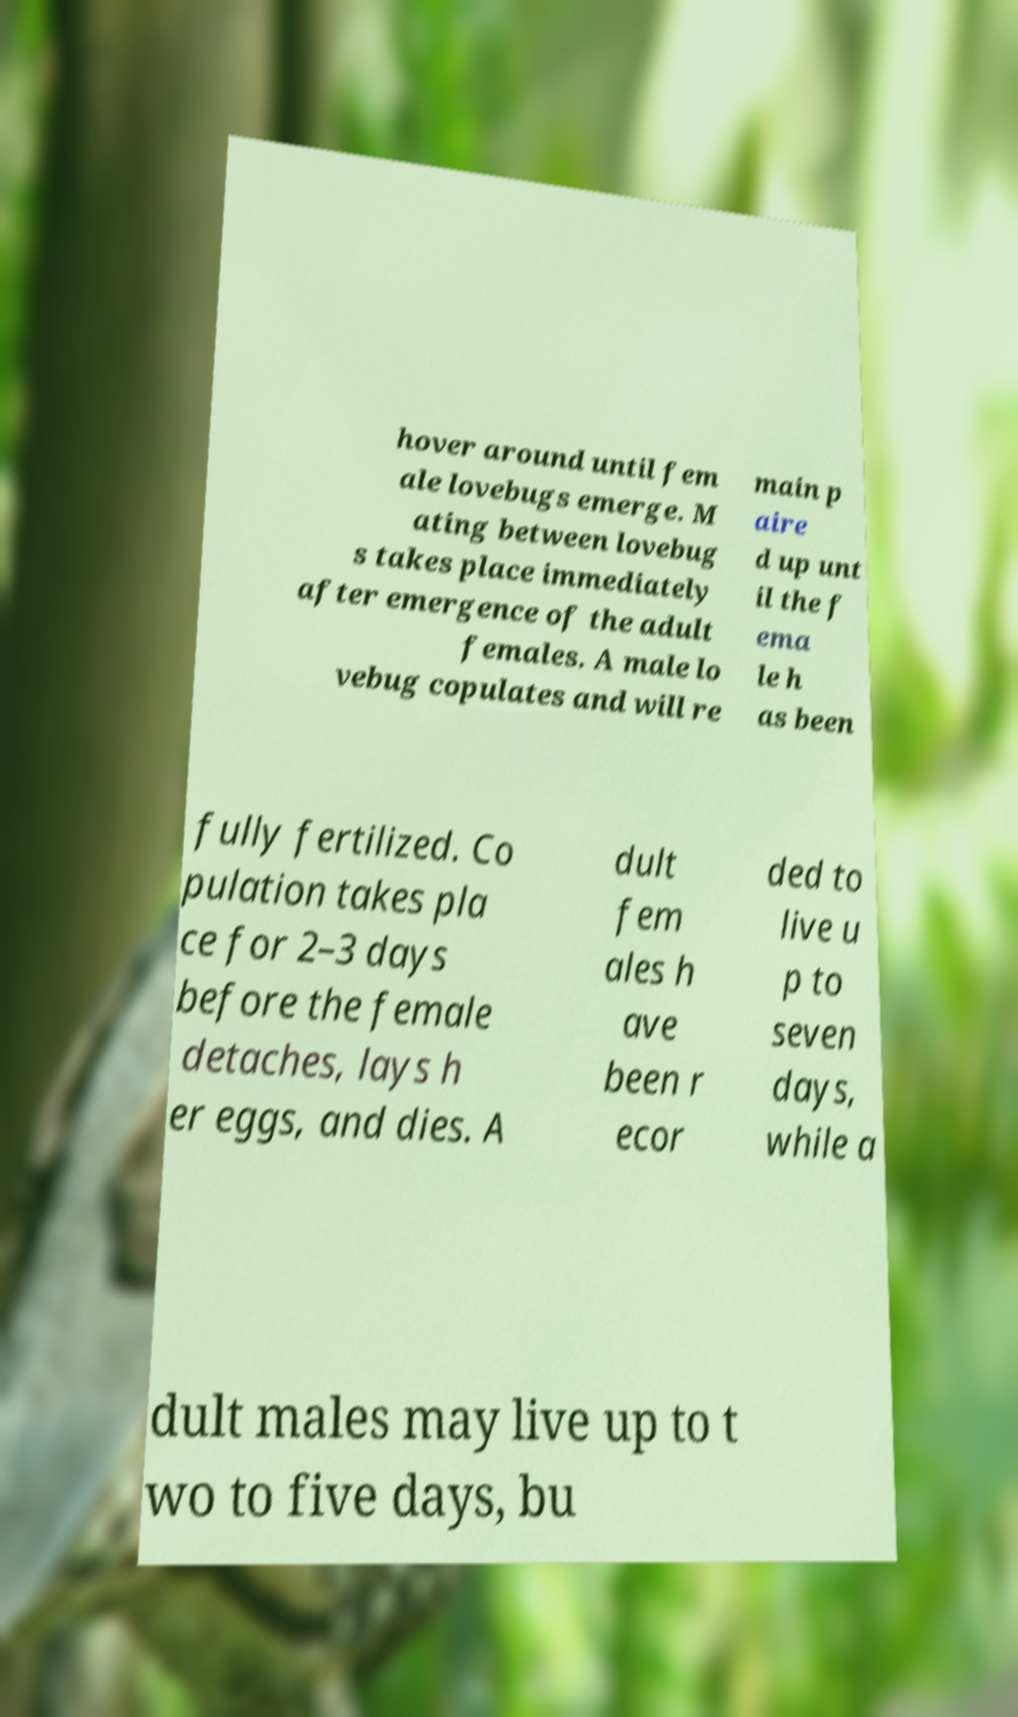There's text embedded in this image that I need extracted. Can you transcribe it verbatim? hover around until fem ale lovebugs emerge. M ating between lovebug s takes place immediately after emergence of the adult females. A male lo vebug copulates and will re main p aire d up unt il the f ema le h as been fully fertilized. Co pulation takes pla ce for 2–3 days before the female detaches, lays h er eggs, and dies. A dult fem ales h ave been r ecor ded to live u p to seven days, while a dult males may live up to t wo to five days, bu 